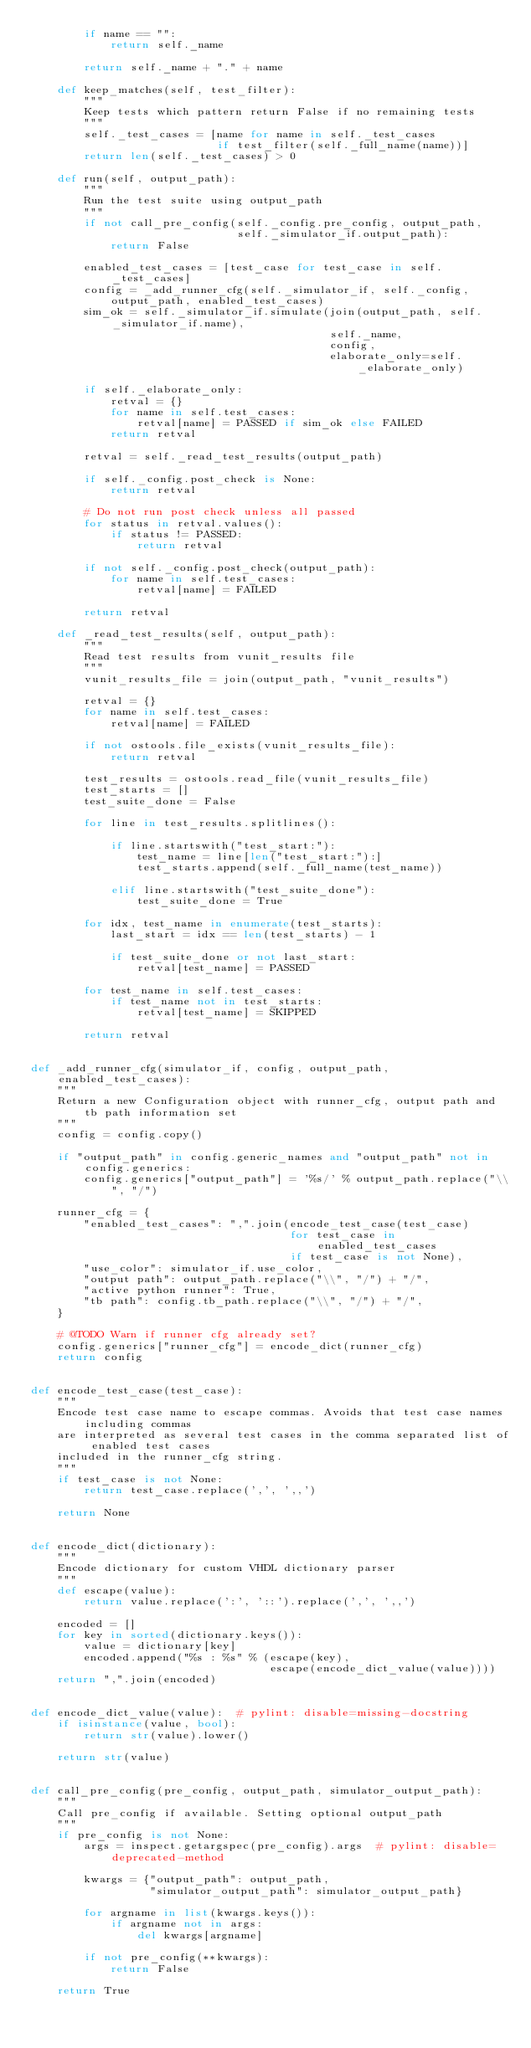Convert code to text. <code><loc_0><loc_0><loc_500><loc_500><_Python_>        if name == "":
            return self._name

        return self._name + "." + name

    def keep_matches(self, test_filter):
        """
        Keep tests which pattern return False if no remaining tests
        """
        self._test_cases = [name for name in self._test_cases
                            if test_filter(self._full_name(name))]
        return len(self._test_cases) > 0

    def run(self, output_path):
        """
        Run the test suite using output_path
        """
        if not call_pre_config(self._config.pre_config, output_path,
                               self._simulator_if.output_path):
            return False

        enabled_test_cases = [test_case for test_case in self._test_cases]
        config = _add_runner_cfg(self._simulator_if, self._config, output_path, enabled_test_cases)
        sim_ok = self._simulator_if.simulate(join(output_path, self._simulator_if.name),
                                             self._name,
                                             config,
                                             elaborate_only=self._elaborate_only)

        if self._elaborate_only:
            retval = {}
            for name in self.test_cases:
                retval[name] = PASSED if sim_ok else FAILED
            return retval

        retval = self._read_test_results(output_path)

        if self._config.post_check is None:
            return retval

        # Do not run post check unless all passed
        for status in retval.values():
            if status != PASSED:
                return retval

        if not self._config.post_check(output_path):
            for name in self.test_cases:
                retval[name] = FAILED

        return retval

    def _read_test_results(self, output_path):
        """
        Read test results from vunit_results file
        """
        vunit_results_file = join(output_path, "vunit_results")

        retval = {}
        for name in self.test_cases:
            retval[name] = FAILED

        if not ostools.file_exists(vunit_results_file):
            return retval

        test_results = ostools.read_file(vunit_results_file)
        test_starts = []
        test_suite_done = False

        for line in test_results.splitlines():

            if line.startswith("test_start:"):
                test_name = line[len("test_start:"):]
                test_starts.append(self._full_name(test_name))

            elif line.startswith("test_suite_done"):
                test_suite_done = True

        for idx, test_name in enumerate(test_starts):
            last_start = idx == len(test_starts) - 1

            if test_suite_done or not last_start:
                retval[test_name] = PASSED

        for test_name in self.test_cases:
            if test_name not in test_starts:
                retval[test_name] = SKIPPED

        return retval


def _add_runner_cfg(simulator_if, config, output_path, enabled_test_cases):
    """
    Return a new Configuration object with runner_cfg, output path and tb path information set
    """
    config = config.copy()

    if "output_path" in config.generic_names and "output_path" not in config.generics:
        config.generics["output_path"] = '%s/' % output_path.replace("\\", "/")

    runner_cfg = {
        "enabled_test_cases": ",".join(encode_test_case(test_case)
                                       for test_case in enabled_test_cases
                                       if test_case is not None),
        "use_color": simulator_if.use_color,
        "output path": output_path.replace("\\", "/") + "/",
        "active python runner": True,
        "tb path": config.tb_path.replace("\\", "/") + "/",
    }

    # @TODO Warn if runner cfg already set?
    config.generics["runner_cfg"] = encode_dict(runner_cfg)
    return config


def encode_test_case(test_case):
    """
    Encode test case name to escape commas. Avoids that test case names including commas
    are interpreted as several test cases in the comma separated list of enabled test cases
    included in the runner_cfg string.
    """
    if test_case is not None:
        return test_case.replace(',', ',,')

    return None


def encode_dict(dictionary):
    """
    Encode dictionary for custom VHDL dictionary parser
    """
    def escape(value):
        return value.replace(':', '::').replace(',', ',,')

    encoded = []
    for key in sorted(dictionary.keys()):
        value = dictionary[key]
        encoded.append("%s : %s" % (escape(key),
                                    escape(encode_dict_value(value))))
    return ",".join(encoded)


def encode_dict_value(value):  # pylint: disable=missing-docstring
    if isinstance(value, bool):
        return str(value).lower()

    return str(value)


def call_pre_config(pre_config, output_path, simulator_output_path):
    """
    Call pre_config if available. Setting optional output_path
    """
    if pre_config is not None:
        args = inspect.getargspec(pre_config).args  # pylint: disable=deprecated-method

        kwargs = {"output_path": output_path,
                  "simulator_output_path": simulator_output_path}

        for argname in list(kwargs.keys()):
            if argname not in args:
                del kwargs[argname]

        if not pre_config(**kwargs):
            return False

    return True
</code> 